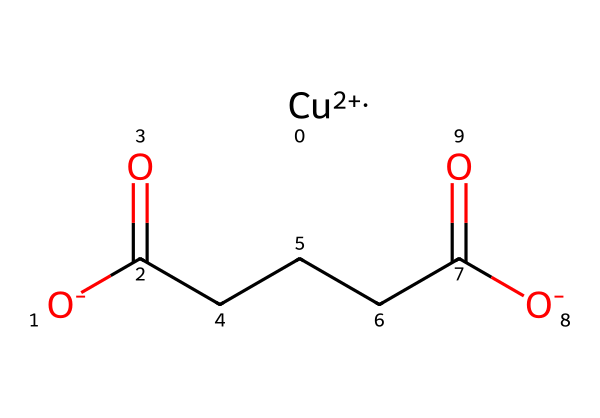What is the central metal atom in verdigris? The SMILES representation indicates the presence of a copper ion (Cu2+) as it is shown at the start, indicating it is the central atom in the chemical structure.
Answer: copper How many carboxylate groups are present in this chemical structure? By analyzing the SMILES, there are two carbon atoms that are part of carboxylate groups, indicated by the -C(=O)O- structure found in the chain, thus there are two of these functional groups.
Answer: two What is the oxidation state of copper in this compound? The notation [Cu+2] shows that the copper is in the +2 oxidation state as denoted by the subscript.
Answer: +2 How many total carbon atoms are in the structure? The sequences of carbon atoms in the structure, including those part of the carboxylate groups, give a total count of five carbon atoms in the entire chemical.
Answer: five What type of chemical is verdigris classified as? Verdigris is known as a copper acetate, indicated by the presence of the copper ion and the carboxylate groups, which are typical of acetate compounds.
Answer: copper acetate 